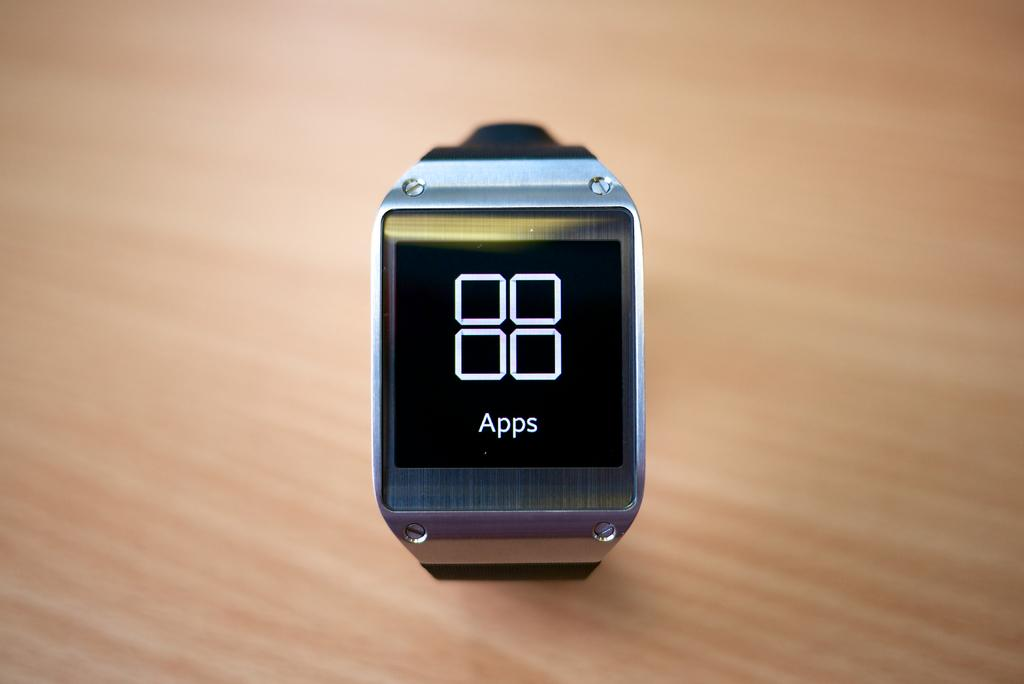<image>
Summarize the visual content of the image. A watch with a digital black screen with four squares on the screen with the word Apps below the squares. 